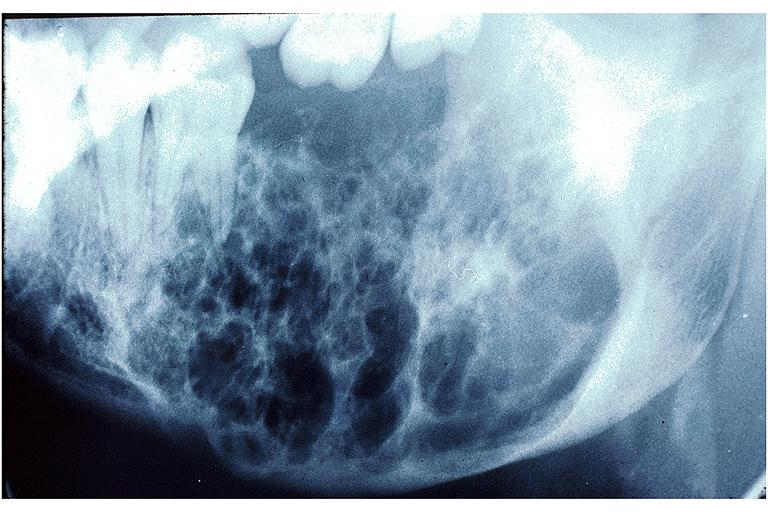where is this?
Answer the question using a single word or phrase. Oral 